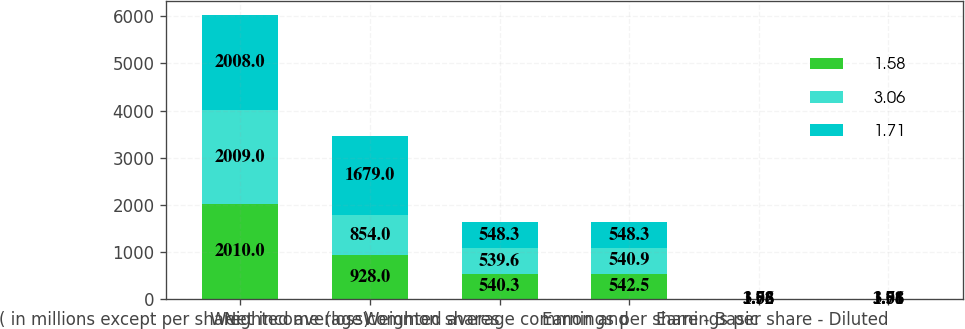Convert chart. <chart><loc_0><loc_0><loc_500><loc_500><stacked_bar_chart><ecel><fcel>( in millions except per share<fcel>Net income (loss)<fcel>Weighted average common shares<fcel>Weighted average common and<fcel>Earnings per share - Basic<fcel>Earnings per share - Diluted<nl><fcel>1.58<fcel>2010<fcel>928<fcel>540.3<fcel>542.5<fcel>1.72<fcel>1.71<nl><fcel>3.06<fcel>2009<fcel>854<fcel>539.6<fcel>540.9<fcel>1.58<fcel>1.58<nl><fcel>1.71<fcel>2008<fcel>1679<fcel>548.3<fcel>548.3<fcel>3.06<fcel>3.06<nl></chart> 